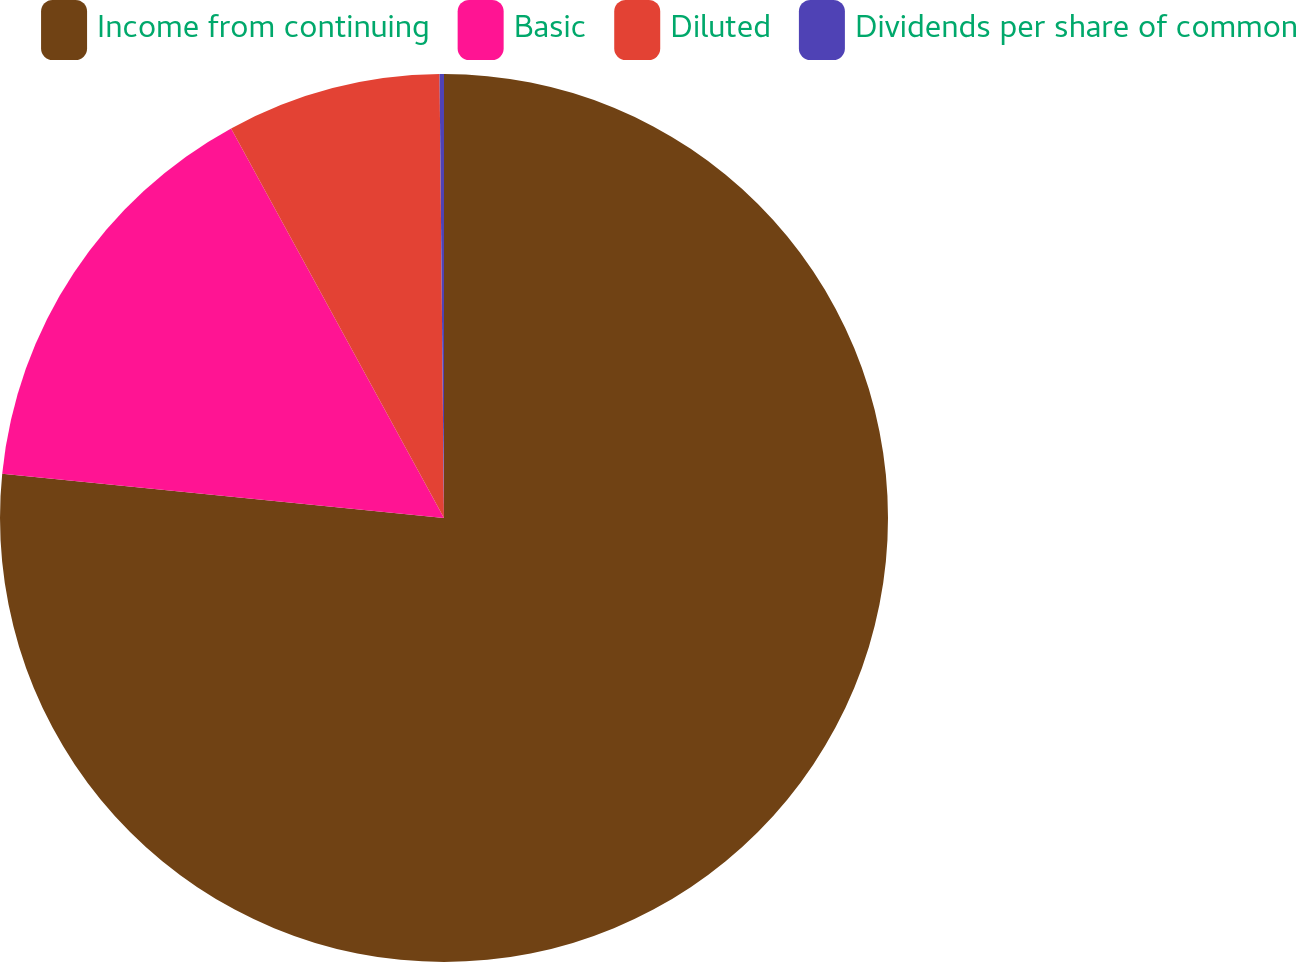Convert chart. <chart><loc_0><loc_0><loc_500><loc_500><pie_chart><fcel>Income from continuing<fcel>Basic<fcel>Diluted<fcel>Dividends per share of common<nl><fcel>76.59%<fcel>15.45%<fcel>7.8%<fcel>0.16%<nl></chart> 